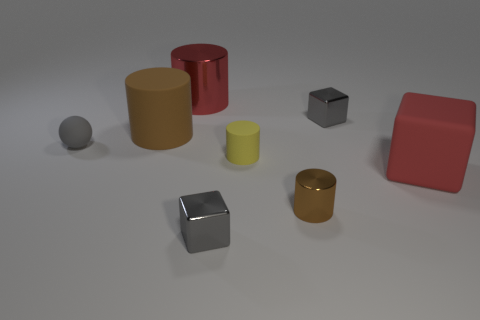Add 1 large red shiny objects. How many objects exist? 9 Subtract all red cubes. How many cubes are left? 2 Subtract all rubber blocks. How many blocks are left? 2 Subtract all blue balls. How many brown cylinders are left? 2 Add 3 red blocks. How many red blocks are left? 4 Add 3 tiny gray matte balls. How many tiny gray matte balls exist? 4 Subtract 0 blue blocks. How many objects are left? 8 Subtract all balls. How many objects are left? 7 Subtract 3 cylinders. How many cylinders are left? 1 Subtract all brown balls. Subtract all brown cubes. How many balls are left? 1 